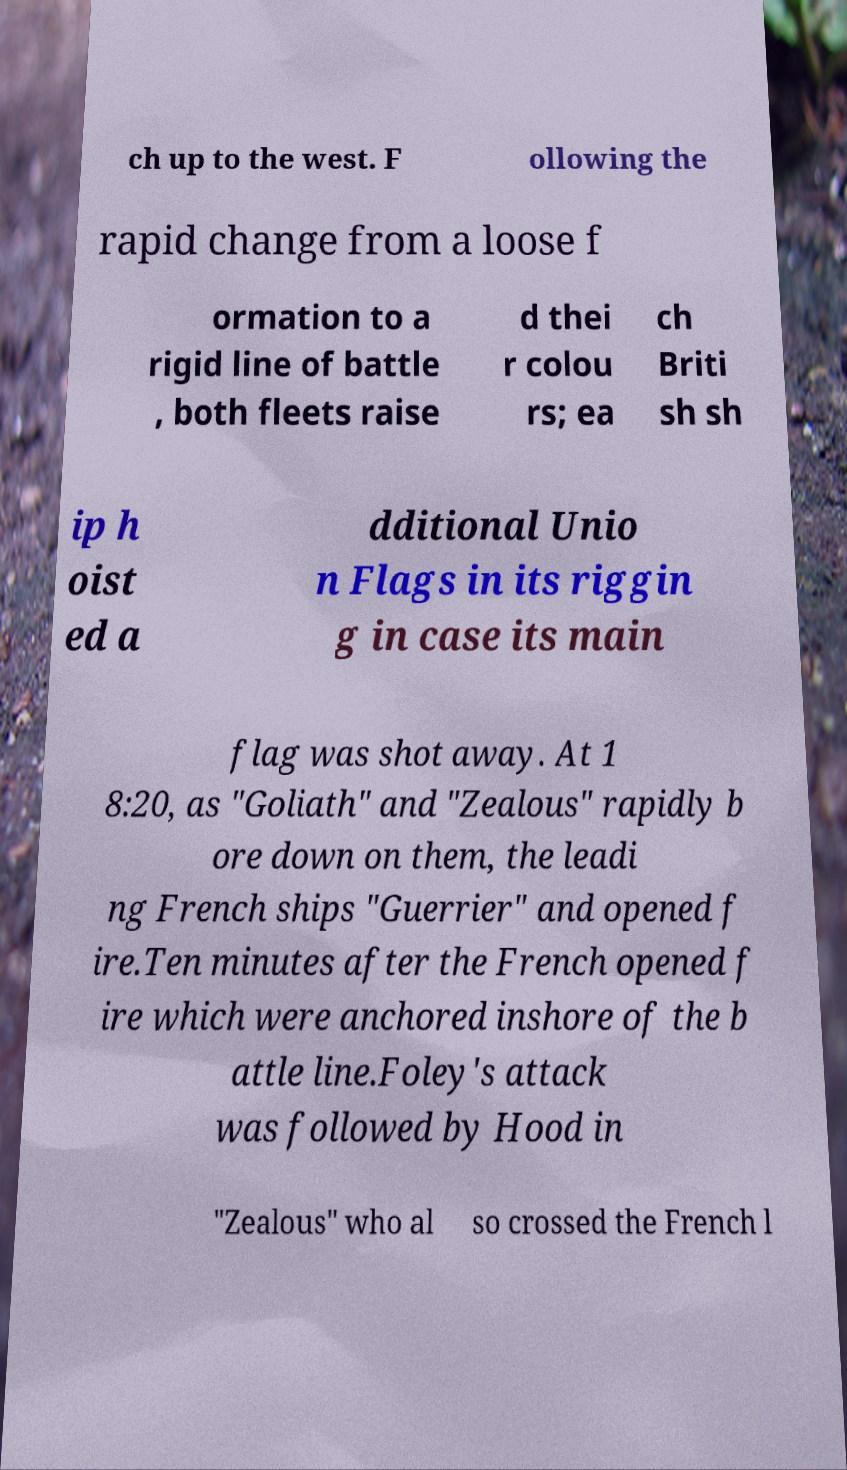Can you accurately transcribe the text from the provided image for me? ch up to the west. F ollowing the rapid change from a loose f ormation to a rigid line of battle , both fleets raise d thei r colou rs; ea ch Briti sh sh ip h oist ed a dditional Unio n Flags in its riggin g in case its main flag was shot away. At 1 8:20, as "Goliath" and "Zealous" rapidly b ore down on them, the leadi ng French ships "Guerrier" and opened f ire.Ten minutes after the French opened f ire which were anchored inshore of the b attle line.Foley's attack was followed by Hood in "Zealous" who al so crossed the French l 